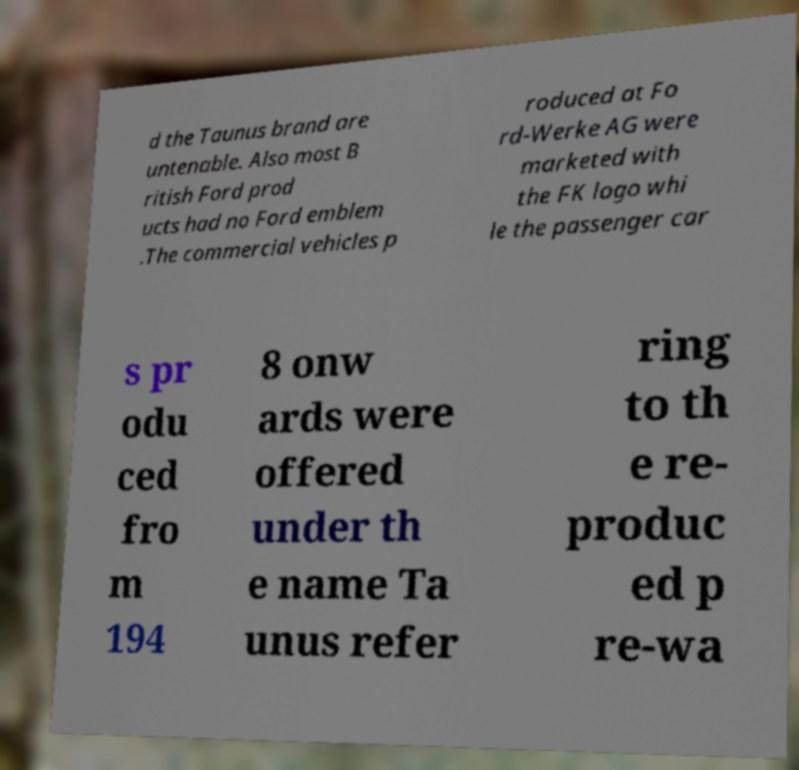Could you extract and type out the text from this image? d the Taunus brand are untenable. Also most B ritish Ford prod ucts had no Ford emblem .The commercial vehicles p roduced at Fo rd-Werke AG were marketed with the FK logo whi le the passenger car s pr odu ced fro m 194 8 onw ards were offered under th e name Ta unus refer ring to th e re- produc ed p re-wa 